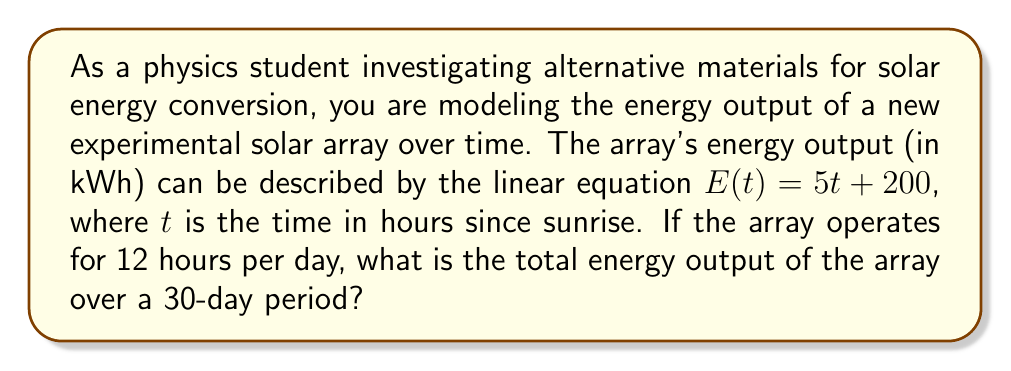Help me with this question. To solve this problem, we'll follow these steps:

1) First, let's understand what the equation $E(t) = 5t + 200$ represents:
   - $E(t)$ is the energy output in kWh
   - $t$ is the time in hours since sunrise
   - The array produces 200 kWh at sunrise $(t=0)$ and increases by 5 kWh each hour

2) We need to find the total energy produced in one day:
   - The array operates for 12 hours per day
   - To find the energy at the end of the day, we substitute $t=12$ into our equation:
     $E(12) = 5(12) + 200 = 60 + 200 = 260$ kWh

3) Now we can calculate the total energy produced in one day:
   - The energy produced is the area under the line from $t=0$ to $t=12$
   - This is a trapezoid with bases 200 and 260, and height 12
   - Area of a trapezoid = $\frac{1}{2}(b_1 + b_2)h$
   - Daily energy = $\frac{1}{2}(200 + 260) \times 12 = 230 \times 12 = 2760$ kWh

4) Finally, we calculate the total energy for 30 days:
   - Total energy = Daily energy $\times$ 30
   - Total energy = $2760 \times 30 = 82800$ kWh

Therefore, the total energy output of the array over a 30-day period is 82800 kWh.
Answer: 82800 kWh 